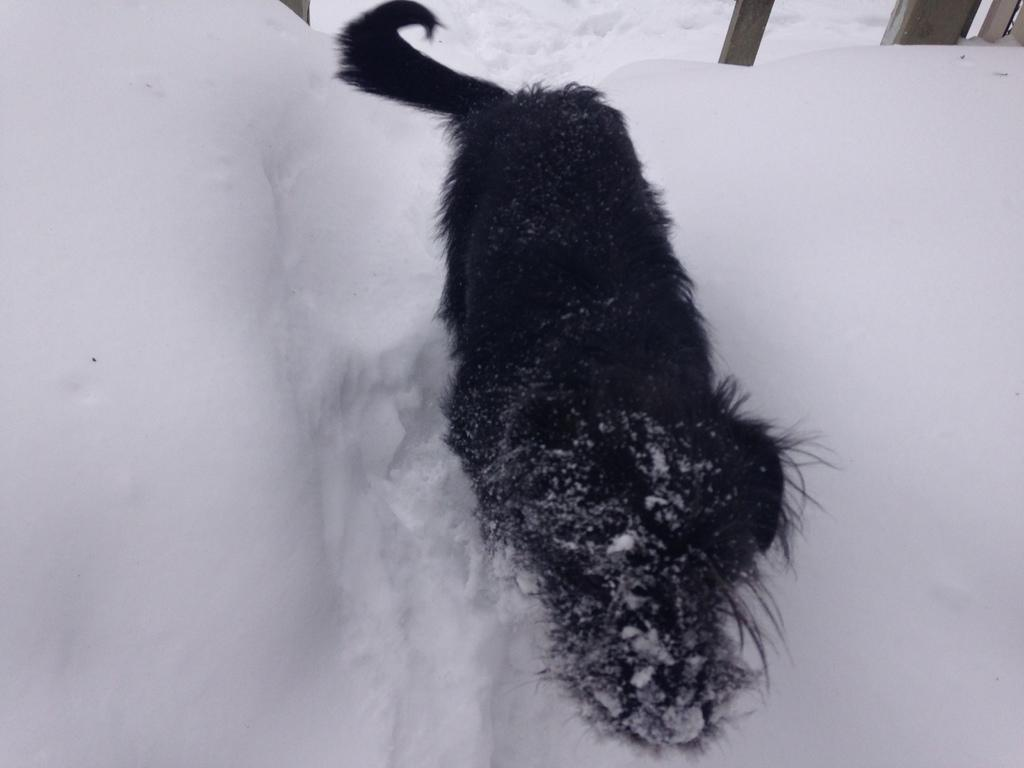What type of animal is in the image? There is a black dog in the image. Where is the dog located? The dog is in the snow. What objects can be seen at the top of the image? There are wooden sticks visible at the top of the image. What type of trade is being conducted in the image? There is no trade being conducted in the image; it features a black dog in the snow with wooden sticks visible at the top. 